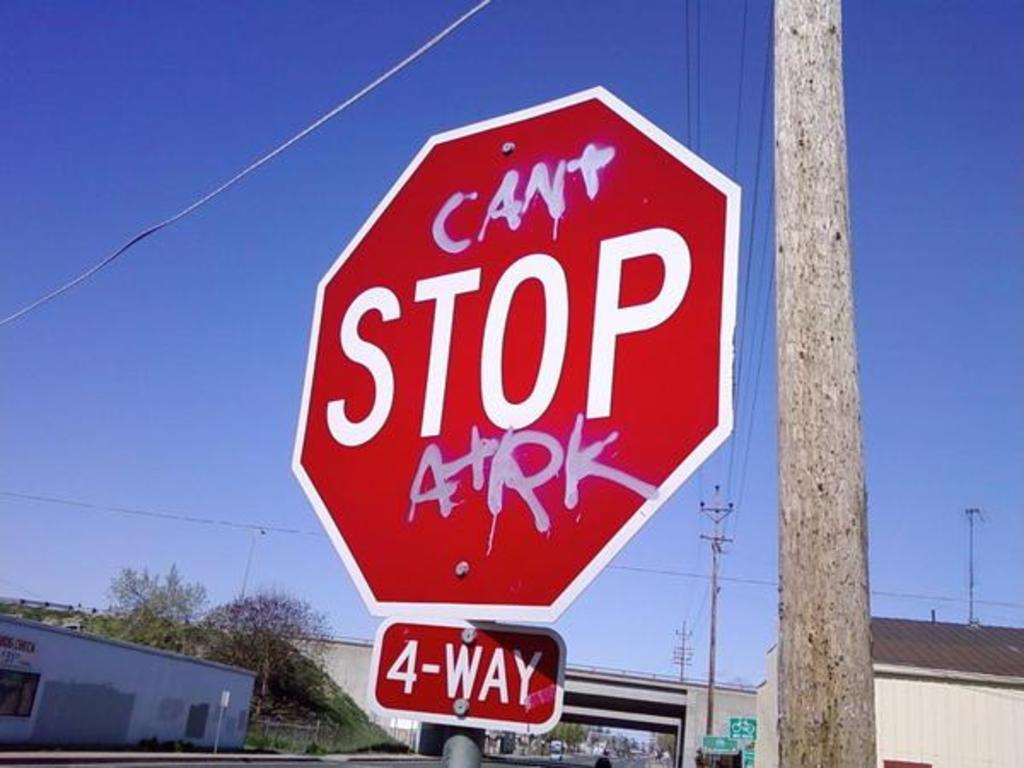<image>
Render a clear and concise summary of the photo. The little sign below the stop sign says that this is a 4-way stop. 